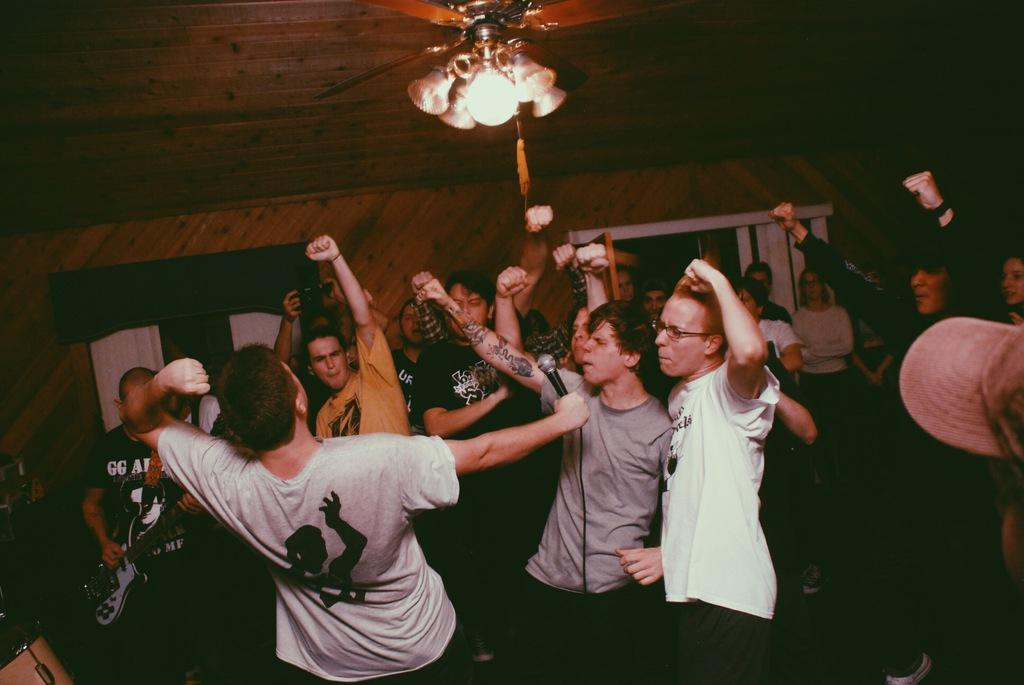What are the people in the image doing? There are many people dancing in the image. What can be seen on the ceiling in the image? There are lights on the ceiling. Who is holding a microphone in the image? A man is holding a microphone in the front. What instrument is being played on the left side of the image? A man is playing a guitar on the left side of the image. How many snails are crawling on the guitar in the image? There are no snails present in the image, and therefore no snails are crawling on the guitar. 